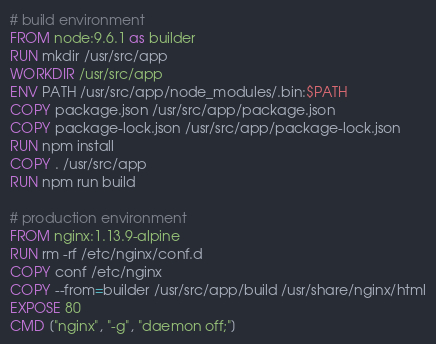<code> <loc_0><loc_0><loc_500><loc_500><_Dockerfile_># build environment
FROM node:9.6.1 as builder
RUN mkdir /usr/src/app
WORKDIR /usr/src/app
ENV PATH /usr/src/app/node_modules/.bin:$PATH
COPY package.json /usr/src/app/package.json
COPY package-lock.json /usr/src/app/package-lock.json
RUN npm install
COPY . /usr/src/app
RUN npm run build

# production environment
FROM nginx:1.13.9-alpine
RUN rm -rf /etc/nginx/conf.d
COPY conf /etc/nginx
COPY --from=builder /usr/src/app/build /usr/share/nginx/html
EXPOSE 80
CMD ["nginx", "-g", "daemon off;"]</code> 